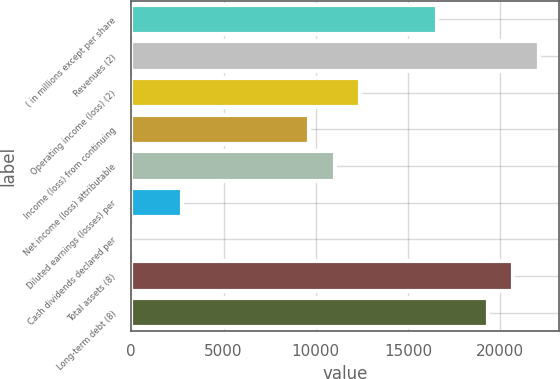Convert chart. <chart><loc_0><loc_0><loc_500><loc_500><bar_chart><fcel>( in millions except per share<fcel>Revenues (2)<fcel>Operating income (loss) (2)<fcel>Income (loss) from continuing<fcel>Net income (loss) attributable<fcel>Diluted earnings (losses) per<fcel>Cash dividends declared per<fcel>Total assets (8)<fcel>Long-term debt (8)<nl><fcel>16555<fcel>22073.1<fcel>12416.5<fcel>9657.41<fcel>11036.9<fcel>2759.81<fcel>0.77<fcel>20693.6<fcel>19314<nl></chart> 